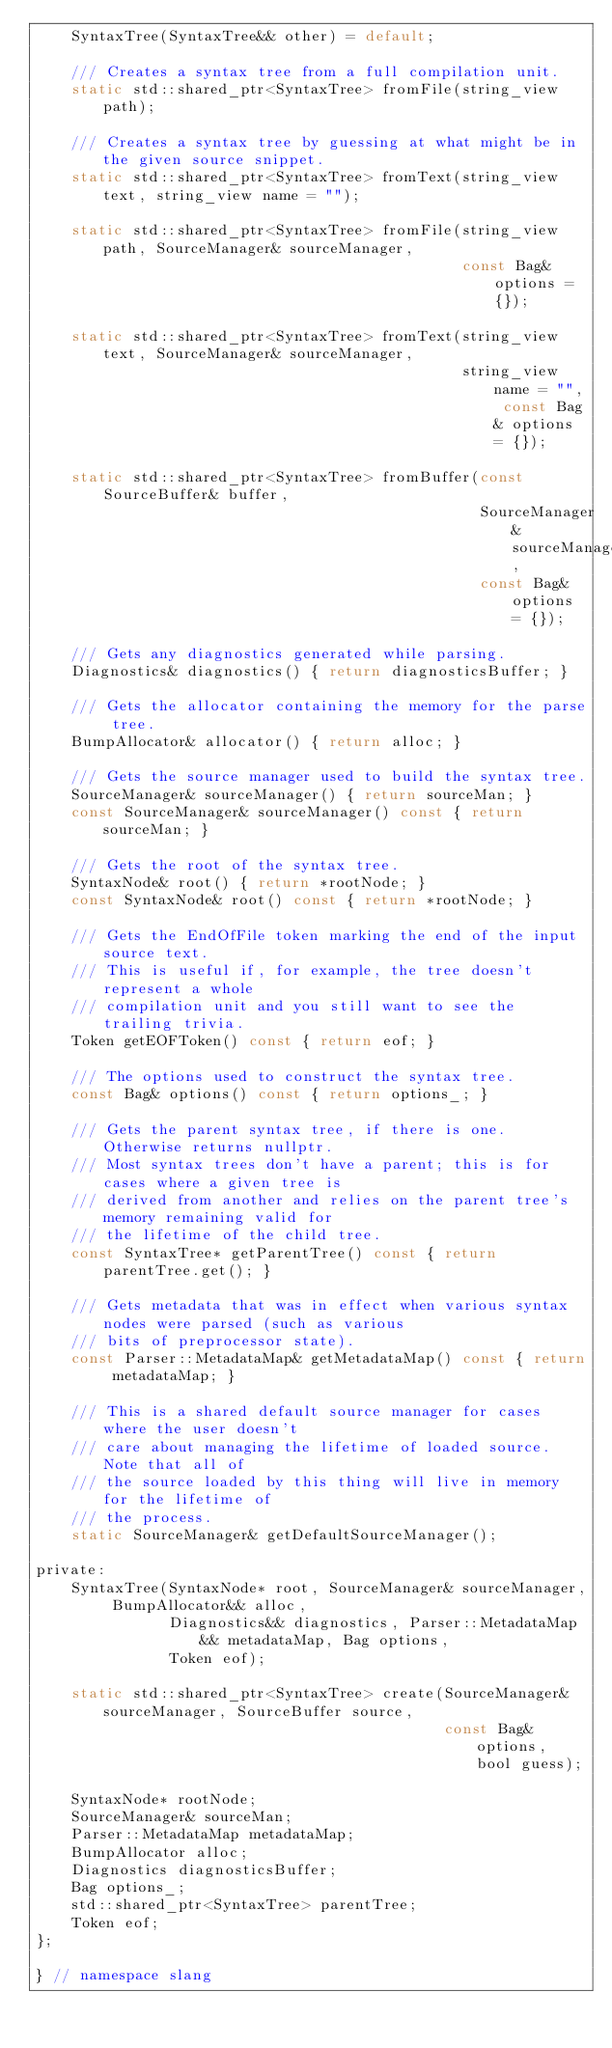<code> <loc_0><loc_0><loc_500><loc_500><_C_>    SyntaxTree(SyntaxTree&& other) = default;

    /// Creates a syntax tree from a full compilation unit.
    static std::shared_ptr<SyntaxTree> fromFile(string_view path);

    /// Creates a syntax tree by guessing at what might be in the given source snippet.
    static std::shared_ptr<SyntaxTree> fromText(string_view text, string_view name = "");

    static std::shared_ptr<SyntaxTree> fromFile(string_view path, SourceManager& sourceManager,
                                                const Bag& options = {});

    static std::shared_ptr<SyntaxTree> fromText(string_view text, SourceManager& sourceManager,
                                                string_view name = "", const Bag& options = {});

    static std::shared_ptr<SyntaxTree> fromBuffer(const SourceBuffer& buffer,
                                                  SourceManager& sourceManager,
                                                  const Bag& options = {});

    /// Gets any diagnostics generated while parsing.
    Diagnostics& diagnostics() { return diagnosticsBuffer; }

    /// Gets the allocator containing the memory for the parse tree.
    BumpAllocator& allocator() { return alloc; }

    /// Gets the source manager used to build the syntax tree.
    SourceManager& sourceManager() { return sourceMan; }
    const SourceManager& sourceManager() const { return sourceMan; }

    /// Gets the root of the syntax tree.
    SyntaxNode& root() { return *rootNode; }
    const SyntaxNode& root() const { return *rootNode; }

    /// Gets the EndOfFile token marking the end of the input source text.
    /// This is useful if, for example, the tree doesn't represent a whole
    /// compilation unit and you still want to see the trailing trivia.
    Token getEOFToken() const { return eof; }

    /// The options used to construct the syntax tree.
    const Bag& options() const { return options_; }

    /// Gets the parent syntax tree, if there is one. Otherwise returns nullptr.
    /// Most syntax trees don't have a parent; this is for cases where a given tree is
    /// derived from another and relies on the parent tree's memory remaining valid for
    /// the lifetime of the child tree.
    const SyntaxTree* getParentTree() const { return parentTree.get(); }

    /// Gets metadata that was in effect when various syntax nodes were parsed (such as various
    /// bits of preprocessor state).
    const Parser::MetadataMap& getMetadataMap() const { return metadataMap; }

    /// This is a shared default source manager for cases where the user doesn't
    /// care about managing the lifetime of loaded source. Note that all of
    /// the source loaded by this thing will live in memory for the lifetime of
    /// the process.
    static SourceManager& getDefaultSourceManager();

private:
    SyntaxTree(SyntaxNode* root, SourceManager& sourceManager, BumpAllocator&& alloc,
               Diagnostics&& diagnostics, Parser::MetadataMap&& metadataMap, Bag options,
               Token eof);

    static std::shared_ptr<SyntaxTree> create(SourceManager& sourceManager, SourceBuffer source,
                                              const Bag& options, bool guess);

    SyntaxNode* rootNode;
    SourceManager& sourceMan;
    Parser::MetadataMap metadataMap;
    BumpAllocator alloc;
    Diagnostics diagnosticsBuffer;
    Bag options_;
    std::shared_ptr<SyntaxTree> parentTree;
    Token eof;
};

} // namespace slang
</code> 